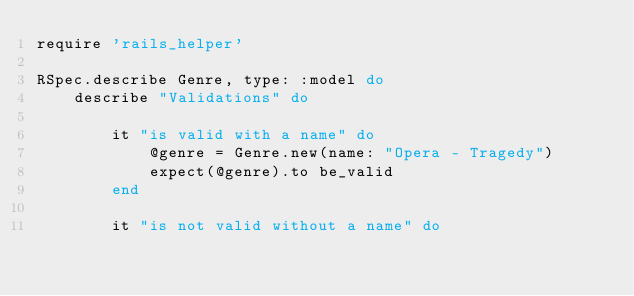<code> <loc_0><loc_0><loc_500><loc_500><_Ruby_>require 'rails_helper'

RSpec.describe Genre, type: :model do
    describe "Validations" do

        it "is valid with a name" do
            @genre = Genre.new(name: "Opera - Tragedy")
            expect(@genre).to be_valid
        end

        it "is not valid without a name" do</code> 